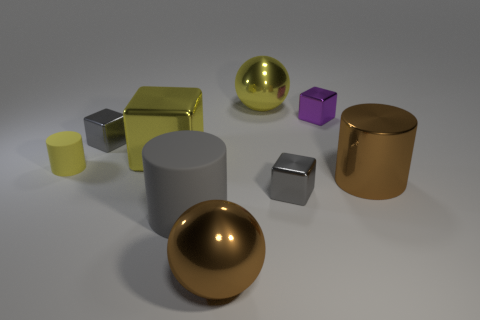What number of blue metallic balls are there?
Your answer should be very brief. 0. Is there any other thing that has the same shape as the small yellow object?
Give a very brief answer. Yes. Is the material of the tiny gray block on the left side of the big yellow shiny block the same as the big sphere that is in front of the large rubber cylinder?
Your response must be concise. Yes. What is the material of the big yellow block?
Provide a succinct answer. Metal. What number of yellow blocks have the same material as the gray cylinder?
Give a very brief answer. 0. What number of matte things are tiny cylinders or tiny gray blocks?
Your answer should be very brief. 1. There is a matte object right of the yellow rubber object; is it the same shape as the large yellow metallic object to the left of the brown sphere?
Ensure brevity in your answer.  No. The cylinder that is both left of the large yellow metallic sphere and in front of the small matte object is what color?
Your response must be concise. Gray. There is a brown metallic object on the right side of the yellow ball; does it have the same size as the metallic sphere that is on the right side of the brown metal ball?
Keep it short and to the point. Yes. What number of small cylinders have the same color as the large rubber cylinder?
Your answer should be compact. 0. 